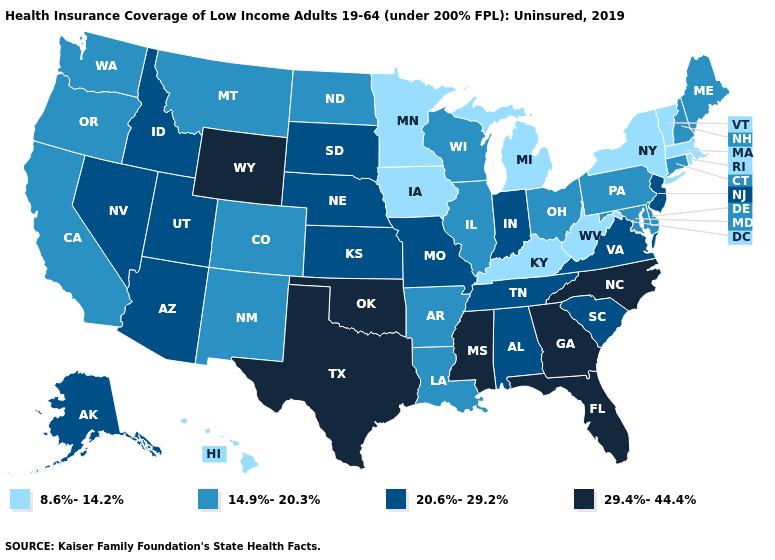Does Ohio have the same value as North Carolina?
Give a very brief answer. No. Name the states that have a value in the range 8.6%-14.2%?
Answer briefly. Hawaii, Iowa, Kentucky, Massachusetts, Michigan, Minnesota, New York, Rhode Island, Vermont, West Virginia. How many symbols are there in the legend?
Give a very brief answer. 4. Does Maine have a lower value than Utah?
Concise answer only. Yes. What is the value of North Carolina?
Be succinct. 29.4%-44.4%. What is the highest value in the Northeast ?
Keep it brief. 20.6%-29.2%. Does Connecticut have a lower value than New Hampshire?
Concise answer only. No. Does Kentucky have the lowest value in the South?
Quick response, please. Yes. What is the lowest value in states that border Minnesota?
Concise answer only. 8.6%-14.2%. Which states have the lowest value in the USA?
Write a very short answer. Hawaii, Iowa, Kentucky, Massachusetts, Michigan, Minnesota, New York, Rhode Island, Vermont, West Virginia. What is the highest value in states that border South Dakota?
Be succinct. 29.4%-44.4%. Among the states that border Utah , does Arizona have the lowest value?
Concise answer only. No. What is the lowest value in the USA?
Write a very short answer. 8.6%-14.2%. Name the states that have a value in the range 14.9%-20.3%?
Be succinct. Arkansas, California, Colorado, Connecticut, Delaware, Illinois, Louisiana, Maine, Maryland, Montana, New Hampshire, New Mexico, North Dakota, Ohio, Oregon, Pennsylvania, Washington, Wisconsin. Does the first symbol in the legend represent the smallest category?
Quick response, please. Yes. 